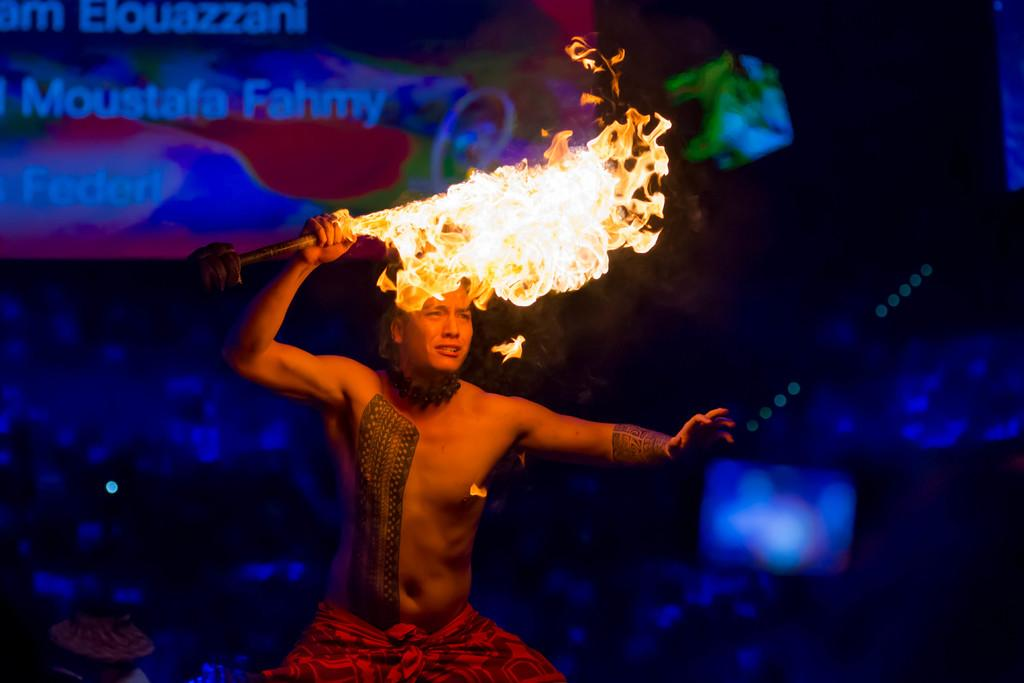What is the main subject of the image? There is a person in the image. What is the person holding in the image? The person is holding a stick with fire. Can you describe the background of the image? The background of the image is blurred. What can be seen at the top of the image? There is a banner visible at the top of the image. What is written on the banner? There is text on the banner. What type of voice can be heard coming from the box in the image? There is no box present in the image, so it's not possible to determine what, if any, voice might be heard. 